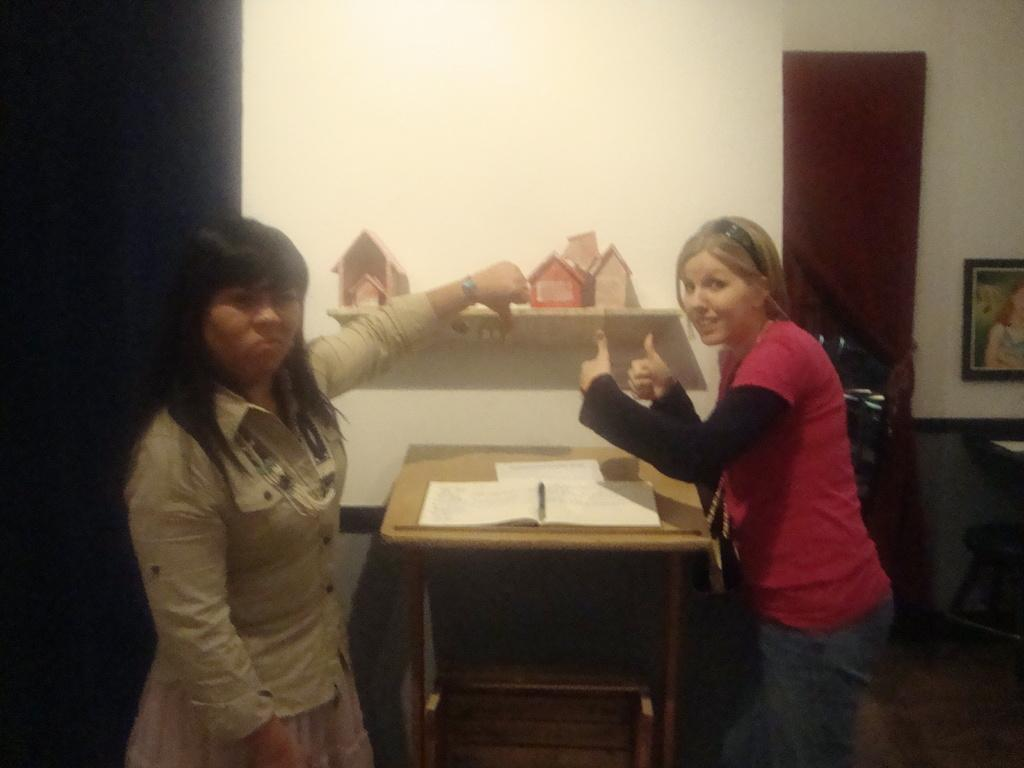How many people are in the image? There are two people in the image. What are the people doing in the image? The people are standing on opposite sides of a table. What objects can be seen on the table? There are books on the table. Where is the photo frame located in the image? The photo frame is in the right corner of the image. What type of hammer is being used by the women in the image? There are no women or hammers present in the image. How many screws can be seen in the image? There are no screws visible in the image. 